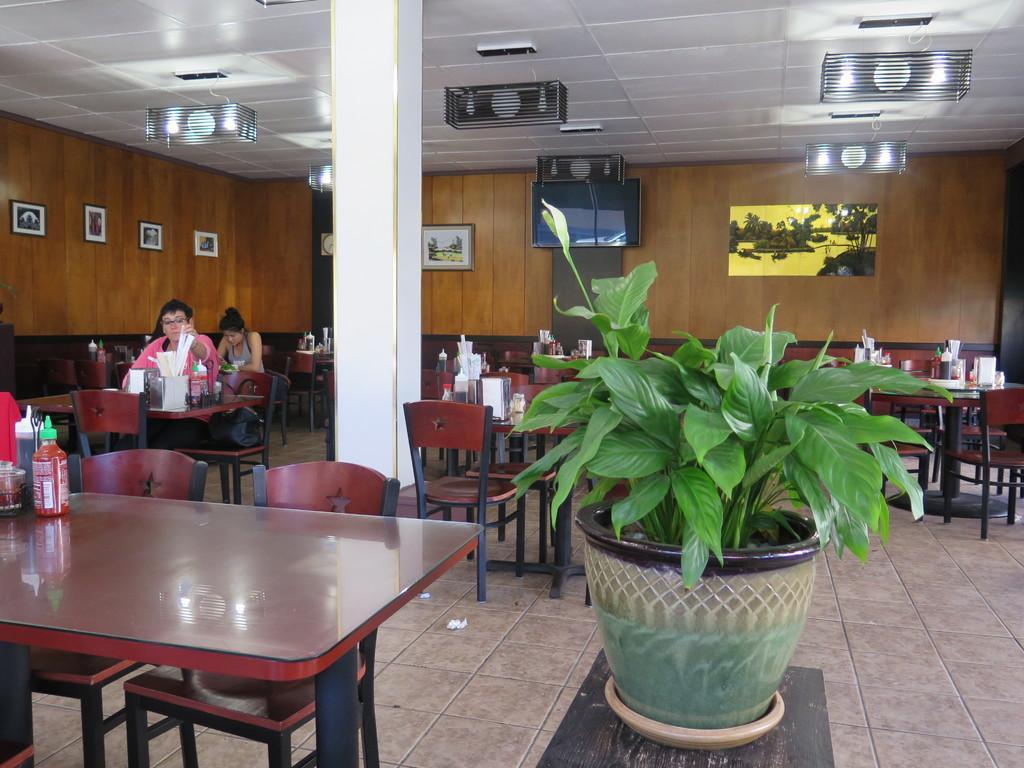Could you give a brief overview of what you see in this image? In this image I can see few people are sitting on chairs. I can also see few more tables and chairs. On these tables I can see few bottles. Here I can see a plant and in the background on these walls I can see few frames, a clock, a television and a painting. 